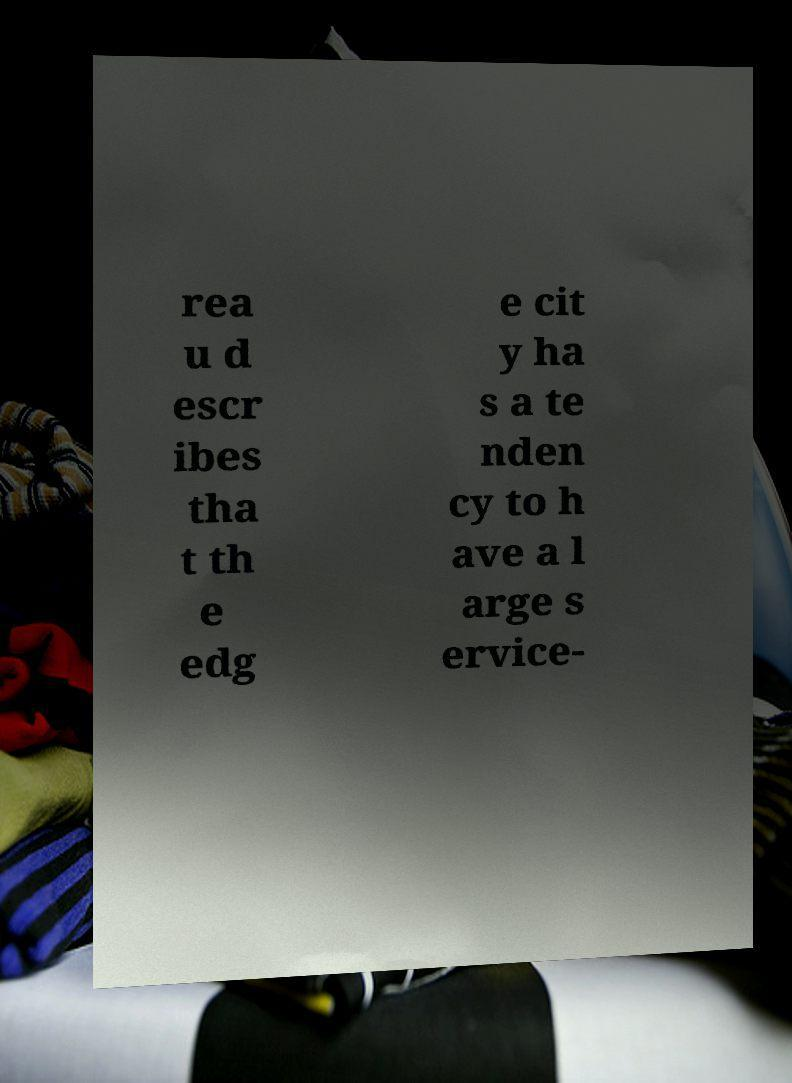Please read and relay the text visible in this image. What does it say? rea u d escr ibes tha t th e edg e cit y ha s a te nden cy to h ave a l arge s ervice- 